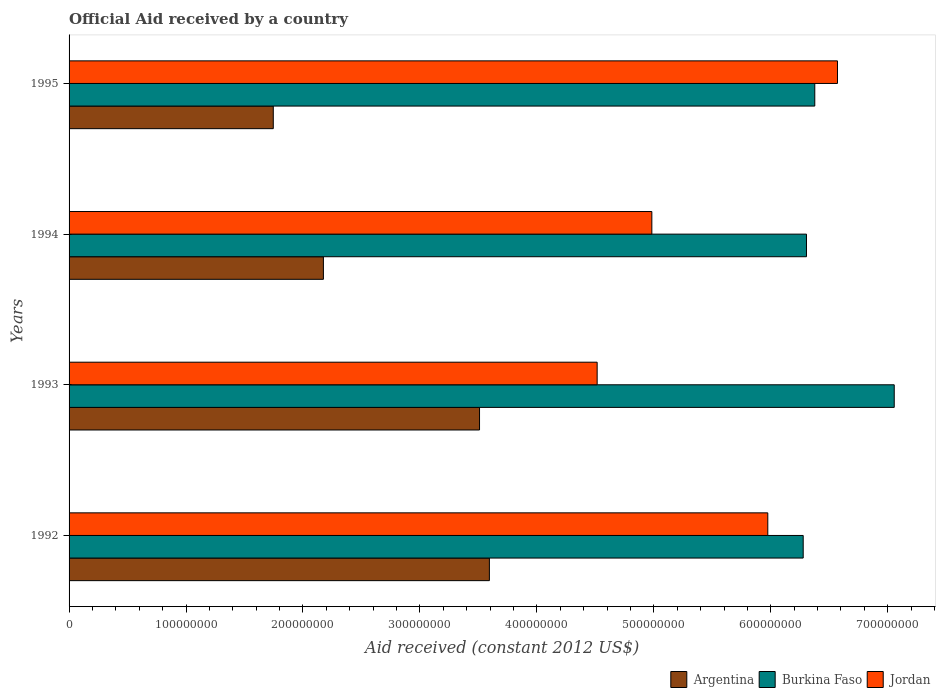How many different coloured bars are there?
Provide a short and direct response. 3. How many groups of bars are there?
Make the answer very short. 4. Are the number of bars per tick equal to the number of legend labels?
Offer a very short reply. Yes. How many bars are there on the 4th tick from the top?
Give a very brief answer. 3. How many bars are there on the 2nd tick from the bottom?
Keep it short and to the point. 3. What is the net official aid received in Jordan in 1994?
Make the answer very short. 4.98e+08. Across all years, what is the maximum net official aid received in Argentina?
Your answer should be very brief. 3.59e+08. Across all years, what is the minimum net official aid received in Burkina Faso?
Your answer should be very brief. 6.28e+08. What is the total net official aid received in Jordan in the graph?
Your response must be concise. 2.20e+09. What is the difference between the net official aid received in Burkina Faso in 1993 and that in 1995?
Ensure brevity in your answer.  6.79e+07. What is the difference between the net official aid received in Jordan in 1992 and the net official aid received in Burkina Faso in 1995?
Your response must be concise. -4.02e+07. What is the average net official aid received in Jordan per year?
Make the answer very short. 5.51e+08. In the year 1994, what is the difference between the net official aid received in Burkina Faso and net official aid received in Argentina?
Provide a succinct answer. 4.13e+08. What is the ratio of the net official aid received in Argentina in 1994 to that in 1995?
Your answer should be compact. 1.25. Is the difference between the net official aid received in Burkina Faso in 1992 and 1994 greater than the difference between the net official aid received in Argentina in 1992 and 1994?
Make the answer very short. No. What is the difference between the highest and the second highest net official aid received in Jordan?
Offer a very short reply. 5.96e+07. What is the difference between the highest and the lowest net official aid received in Burkina Faso?
Offer a very short reply. 7.78e+07. Is the sum of the net official aid received in Burkina Faso in 1992 and 1993 greater than the maximum net official aid received in Jordan across all years?
Provide a succinct answer. Yes. What does the 2nd bar from the top in 1994 represents?
Your answer should be compact. Burkina Faso. What does the 1st bar from the bottom in 1995 represents?
Your answer should be very brief. Argentina. Are the values on the major ticks of X-axis written in scientific E-notation?
Ensure brevity in your answer.  No. How many legend labels are there?
Provide a short and direct response. 3. What is the title of the graph?
Your response must be concise. Official Aid received by a country. What is the label or title of the X-axis?
Make the answer very short. Aid received (constant 2012 US$). What is the Aid received (constant 2012 US$) in Argentina in 1992?
Provide a succinct answer. 3.59e+08. What is the Aid received (constant 2012 US$) in Burkina Faso in 1992?
Your answer should be very brief. 6.28e+08. What is the Aid received (constant 2012 US$) in Jordan in 1992?
Ensure brevity in your answer.  5.97e+08. What is the Aid received (constant 2012 US$) in Argentina in 1993?
Make the answer very short. 3.51e+08. What is the Aid received (constant 2012 US$) of Burkina Faso in 1993?
Your response must be concise. 7.06e+08. What is the Aid received (constant 2012 US$) of Jordan in 1993?
Provide a succinct answer. 4.52e+08. What is the Aid received (constant 2012 US$) in Argentina in 1994?
Ensure brevity in your answer.  2.17e+08. What is the Aid received (constant 2012 US$) of Burkina Faso in 1994?
Make the answer very short. 6.31e+08. What is the Aid received (constant 2012 US$) of Jordan in 1994?
Keep it short and to the point. 4.98e+08. What is the Aid received (constant 2012 US$) in Argentina in 1995?
Offer a very short reply. 1.75e+08. What is the Aid received (constant 2012 US$) of Burkina Faso in 1995?
Make the answer very short. 6.38e+08. What is the Aid received (constant 2012 US$) in Jordan in 1995?
Give a very brief answer. 6.57e+08. Across all years, what is the maximum Aid received (constant 2012 US$) in Argentina?
Your response must be concise. 3.59e+08. Across all years, what is the maximum Aid received (constant 2012 US$) in Burkina Faso?
Make the answer very short. 7.06e+08. Across all years, what is the maximum Aid received (constant 2012 US$) in Jordan?
Make the answer very short. 6.57e+08. Across all years, what is the minimum Aid received (constant 2012 US$) in Argentina?
Provide a short and direct response. 1.75e+08. Across all years, what is the minimum Aid received (constant 2012 US$) of Burkina Faso?
Offer a very short reply. 6.28e+08. Across all years, what is the minimum Aid received (constant 2012 US$) of Jordan?
Provide a succinct answer. 4.52e+08. What is the total Aid received (constant 2012 US$) in Argentina in the graph?
Your answer should be very brief. 1.10e+09. What is the total Aid received (constant 2012 US$) of Burkina Faso in the graph?
Your response must be concise. 2.60e+09. What is the total Aid received (constant 2012 US$) of Jordan in the graph?
Offer a terse response. 2.20e+09. What is the difference between the Aid received (constant 2012 US$) in Argentina in 1992 and that in 1993?
Your answer should be compact. 8.43e+06. What is the difference between the Aid received (constant 2012 US$) in Burkina Faso in 1992 and that in 1993?
Offer a very short reply. -7.78e+07. What is the difference between the Aid received (constant 2012 US$) of Jordan in 1992 and that in 1993?
Provide a succinct answer. 1.46e+08. What is the difference between the Aid received (constant 2012 US$) in Argentina in 1992 and that in 1994?
Provide a succinct answer. 1.42e+08. What is the difference between the Aid received (constant 2012 US$) of Burkina Faso in 1992 and that in 1994?
Offer a terse response. -2.81e+06. What is the difference between the Aid received (constant 2012 US$) in Jordan in 1992 and that in 1994?
Make the answer very short. 9.91e+07. What is the difference between the Aid received (constant 2012 US$) in Argentina in 1992 and that in 1995?
Your answer should be very brief. 1.85e+08. What is the difference between the Aid received (constant 2012 US$) of Burkina Faso in 1992 and that in 1995?
Give a very brief answer. -9.91e+06. What is the difference between the Aid received (constant 2012 US$) of Jordan in 1992 and that in 1995?
Ensure brevity in your answer.  -5.96e+07. What is the difference between the Aid received (constant 2012 US$) in Argentina in 1993 and that in 1994?
Make the answer very short. 1.33e+08. What is the difference between the Aid received (constant 2012 US$) in Burkina Faso in 1993 and that in 1994?
Your answer should be compact. 7.50e+07. What is the difference between the Aid received (constant 2012 US$) of Jordan in 1993 and that in 1994?
Give a very brief answer. -4.68e+07. What is the difference between the Aid received (constant 2012 US$) of Argentina in 1993 and that in 1995?
Make the answer very short. 1.76e+08. What is the difference between the Aid received (constant 2012 US$) in Burkina Faso in 1993 and that in 1995?
Your answer should be very brief. 6.79e+07. What is the difference between the Aid received (constant 2012 US$) of Jordan in 1993 and that in 1995?
Offer a terse response. -2.06e+08. What is the difference between the Aid received (constant 2012 US$) of Argentina in 1994 and that in 1995?
Give a very brief answer. 4.29e+07. What is the difference between the Aid received (constant 2012 US$) of Burkina Faso in 1994 and that in 1995?
Offer a very short reply. -7.10e+06. What is the difference between the Aid received (constant 2012 US$) in Jordan in 1994 and that in 1995?
Make the answer very short. -1.59e+08. What is the difference between the Aid received (constant 2012 US$) in Argentina in 1992 and the Aid received (constant 2012 US$) in Burkina Faso in 1993?
Keep it short and to the point. -3.46e+08. What is the difference between the Aid received (constant 2012 US$) of Argentina in 1992 and the Aid received (constant 2012 US$) of Jordan in 1993?
Provide a short and direct response. -9.21e+07. What is the difference between the Aid received (constant 2012 US$) in Burkina Faso in 1992 and the Aid received (constant 2012 US$) in Jordan in 1993?
Keep it short and to the point. 1.76e+08. What is the difference between the Aid received (constant 2012 US$) in Argentina in 1992 and the Aid received (constant 2012 US$) in Burkina Faso in 1994?
Ensure brevity in your answer.  -2.71e+08. What is the difference between the Aid received (constant 2012 US$) of Argentina in 1992 and the Aid received (constant 2012 US$) of Jordan in 1994?
Make the answer very short. -1.39e+08. What is the difference between the Aid received (constant 2012 US$) in Burkina Faso in 1992 and the Aid received (constant 2012 US$) in Jordan in 1994?
Give a very brief answer. 1.29e+08. What is the difference between the Aid received (constant 2012 US$) in Argentina in 1992 and the Aid received (constant 2012 US$) in Burkina Faso in 1995?
Offer a very short reply. -2.78e+08. What is the difference between the Aid received (constant 2012 US$) of Argentina in 1992 and the Aid received (constant 2012 US$) of Jordan in 1995?
Make the answer very short. -2.98e+08. What is the difference between the Aid received (constant 2012 US$) in Burkina Faso in 1992 and the Aid received (constant 2012 US$) in Jordan in 1995?
Offer a very short reply. -2.93e+07. What is the difference between the Aid received (constant 2012 US$) in Argentina in 1993 and the Aid received (constant 2012 US$) in Burkina Faso in 1994?
Your answer should be very brief. -2.80e+08. What is the difference between the Aid received (constant 2012 US$) of Argentina in 1993 and the Aid received (constant 2012 US$) of Jordan in 1994?
Offer a terse response. -1.47e+08. What is the difference between the Aid received (constant 2012 US$) of Burkina Faso in 1993 and the Aid received (constant 2012 US$) of Jordan in 1994?
Provide a short and direct response. 2.07e+08. What is the difference between the Aid received (constant 2012 US$) in Argentina in 1993 and the Aid received (constant 2012 US$) in Burkina Faso in 1995?
Make the answer very short. -2.87e+08. What is the difference between the Aid received (constant 2012 US$) of Argentina in 1993 and the Aid received (constant 2012 US$) of Jordan in 1995?
Ensure brevity in your answer.  -3.06e+08. What is the difference between the Aid received (constant 2012 US$) in Burkina Faso in 1993 and the Aid received (constant 2012 US$) in Jordan in 1995?
Provide a short and direct response. 4.85e+07. What is the difference between the Aid received (constant 2012 US$) in Argentina in 1994 and the Aid received (constant 2012 US$) in Burkina Faso in 1995?
Make the answer very short. -4.20e+08. What is the difference between the Aid received (constant 2012 US$) of Argentina in 1994 and the Aid received (constant 2012 US$) of Jordan in 1995?
Provide a succinct answer. -4.40e+08. What is the difference between the Aid received (constant 2012 US$) of Burkina Faso in 1994 and the Aid received (constant 2012 US$) of Jordan in 1995?
Offer a very short reply. -2.65e+07. What is the average Aid received (constant 2012 US$) of Argentina per year?
Your response must be concise. 2.76e+08. What is the average Aid received (constant 2012 US$) of Burkina Faso per year?
Keep it short and to the point. 6.50e+08. What is the average Aid received (constant 2012 US$) in Jordan per year?
Make the answer very short. 5.51e+08. In the year 1992, what is the difference between the Aid received (constant 2012 US$) in Argentina and Aid received (constant 2012 US$) in Burkina Faso?
Give a very brief answer. -2.68e+08. In the year 1992, what is the difference between the Aid received (constant 2012 US$) of Argentina and Aid received (constant 2012 US$) of Jordan?
Provide a short and direct response. -2.38e+08. In the year 1992, what is the difference between the Aid received (constant 2012 US$) of Burkina Faso and Aid received (constant 2012 US$) of Jordan?
Offer a very short reply. 3.03e+07. In the year 1993, what is the difference between the Aid received (constant 2012 US$) of Argentina and Aid received (constant 2012 US$) of Burkina Faso?
Your answer should be very brief. -3.55e+08. In the year 1993, what is the difference between the Aid received (constant 2012 US$) in Argentina and Aid received (constant 2012 US$) in Jordan?
Your response must be concise. -1.01e+08. In the year 1993, what is the difference between the Aid received (constant 2012 US$) in Burkina Faso and Aid received (constant 2012 US$) in Jordan?
Keep it short and to the point. 2.54e+08. In the year 1994, what is the difference between the Aid received (constant 2012 US$) of Argentina and Aid received (constant 2012 US$) of Burkina Faso?
Make the answer very short. -4.13e+08. In the year 1994, what is the difference between the Aid received (constant 2012 US$) in Argentina and Aid received (constant 2012 US$) in Jordan?
Offer a very short reply. -2.81e+08. In the year 1994, what is the difference between the Aid received (constant 2012 US$) of Burkina Faso and Aid received (constant 2012 US$) of Jordan?
Your answer should be very brief. 1.32e+08. In the year 1995, what is the difference between the Aid received (constant 2012 US$) of Argentina and Aid received (constant 2012 US$) of Burkina Faso?
Make the answer very short. -4.63e+08. In the year 1995, what is the difference between the Aid received (constant 2012 US$) in Argentina and Aid received (constant 2012 US$) in Jordan?
Offer a terse response. -4.82e+08. In the year 1995, what is the difference between the Aid received (constant 2012 US$) of Burkina Faso and Aid received (constant 2012 US$) of Jordan?
Offer a very short reply. -1.94e+07. What is the ratio of the Aid received (constant 2012 US$) of Burkina Faso in 1992 to that in 1993?
Make the answer very short. 0.89. What is the ratio of the Aid received (constant 2012 US$) in Jordan in 1992 to that in 1993?
Provide a succinct answer. 1.32. What is the ratio of the Aid received (constant 2012 US$) in Argentina in 1992 to that in 1994?
Offer a terse response. 1.65. What is the ratio of the Aid received (constant 2012 US$) of Burkina Faso in 1992 to that in 1994?
Provide a short and direct response. 1. What is the ratio of the Aid received (constant 2012 US$) in Jordan in 1992 to that in 1994?
Give a very brief answer. 1.2. What is the ratio of the Aid received (constant 2012 US$) in Argentina in 1992 to that in 1995?
Provide a succinct answer. 2.06. What is the ratio of the Aid received (constant 2012 US$) of Burkina Faso in 1992 to that in 1995?
Your answer should be compact. 0.98. What is the ratio of the Aid received (constant 2012 US$) in Jordan in 1992 to that in 1995?
Offer a terse response. 0.91. What is the ratio of the Aid received (constant 2012 US$) of Argentina in 1993 to that in 1994?
Offer a terse response. 1.61. What is the ratio of the Aid received (constant 2012 US$) of Burkina Faso in 1993 to that in 1994?
Provide a short and direct response. 1.12. What is the ratio of the Aid received (constant 2012 US$) in Jordan in 1993 to that in 1994?
Your response must be concise. 0.91. What is the ratio of the Aid received (constant 2012 US$) of Argentina in 1993 to that in 1995?
Give a very brief answer. 2.01. What is the ratio of the Aid received (constant 2012 US$) in Burkina Faso in 1993 to that in 1995?
Provide a short and direct response. 1.11. What is the ratio of the Aid received (constant 2012 US$) in Jordan in 1993 to that in 1995?
Make the answer very short. 0.69. What is the ratio of the Aid received (constant 2012 US$) in Argentina in 1994 to that in 1995?
Provide a succinct answer. 1.25. What is the ratio of the Aid received (constant 2012 US$) of Burkina Faso in 1994 to that in 1995?
Your response must be concise. 0.99. What is the ratio of the Aid received (constant 2012 US$) of Jordan in 1994 to that in 1995?
Your answer should be compact. 0.76. What is the difference between the highest and the second highest Aid received (constant 2012 US$) of Argentina?
Give a very brief answer. 8.43e+06. What is the difference between the highest and the second highest Aid received (constant 2012 US$) in Burkina Faso?
Your response must be concise. 6.79e+07. What is the difference between the highest and the second highest Aid received (constant 2012 US$) in Jordan?
Provide a succinct answer. 5.96e+07. What is the difference between the highest and the lowest Aid received (constant 2012 US$) in Argentina?
Provide a succinct answer. 1.85e+08. What is the difference between the highest and the lowest Aid received (constant 2012 US$) in Burkina Faso?
Give a very brief answer. 7.78e+07. What is the difference between the highest and the lowest Aid received (constant 2012 US$) in Jordan?
Ensure brevity in your answer.  2.06e+08. 